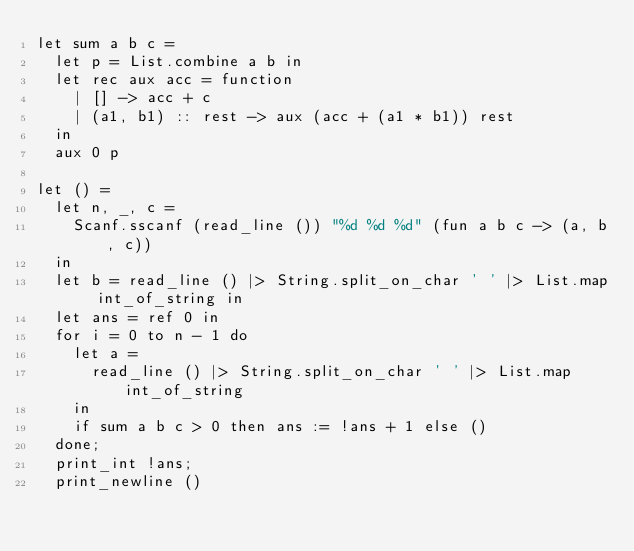<code> <loc_0><loc_0><loc_500><loc_500><_OCaml_>let sum a b c =
  let p = List.combine a b in
  let rec aux acc = function
    | [] -> acc + c
    | (a1, b1) :: rest -> aux (acc + (a1 * b1)) rest
  in
  aux 0 p

let () =
  let n, _, c =
    Scanf.sscanf (read_line ()) "%d %d %d" (fun a b c -> (a, b, c))
  in
  let b = read_line () |> String.split_on_char ' ' |> List.map int_of_string in
  let ans = ref 0 in
  for i = 0 to n - 1 do
    let a =
      read_line () |> String.split_on_char ' ' |> List.map int_of_string
    in
    if sum a b c > 0 then ans := !ans + 1 else ()
  done;
  print_int !ans;
  print_newline ()
</code> 